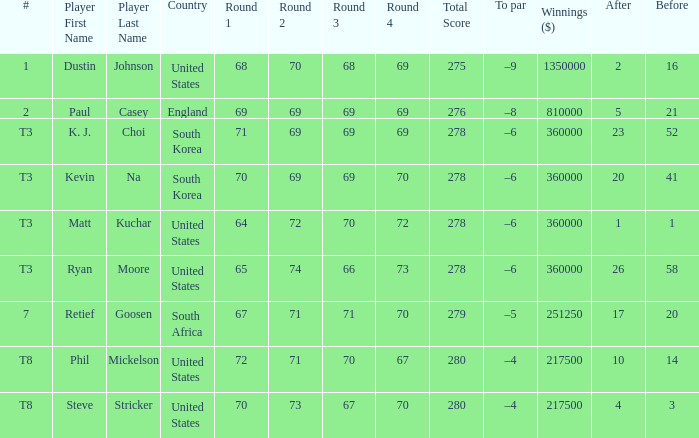How many times is  a to par listed when the player is phil mickelson? 1.0. 